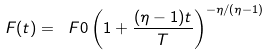<formula> <loc_0><loc_0><loc_500><loc_500>F ( t ) = \ F 0 \left ( 1 + \frac { ( \eta - 1 ) t } { T } \right ) ^ { - \eta / ( \eta - 1 ) }</formula> 